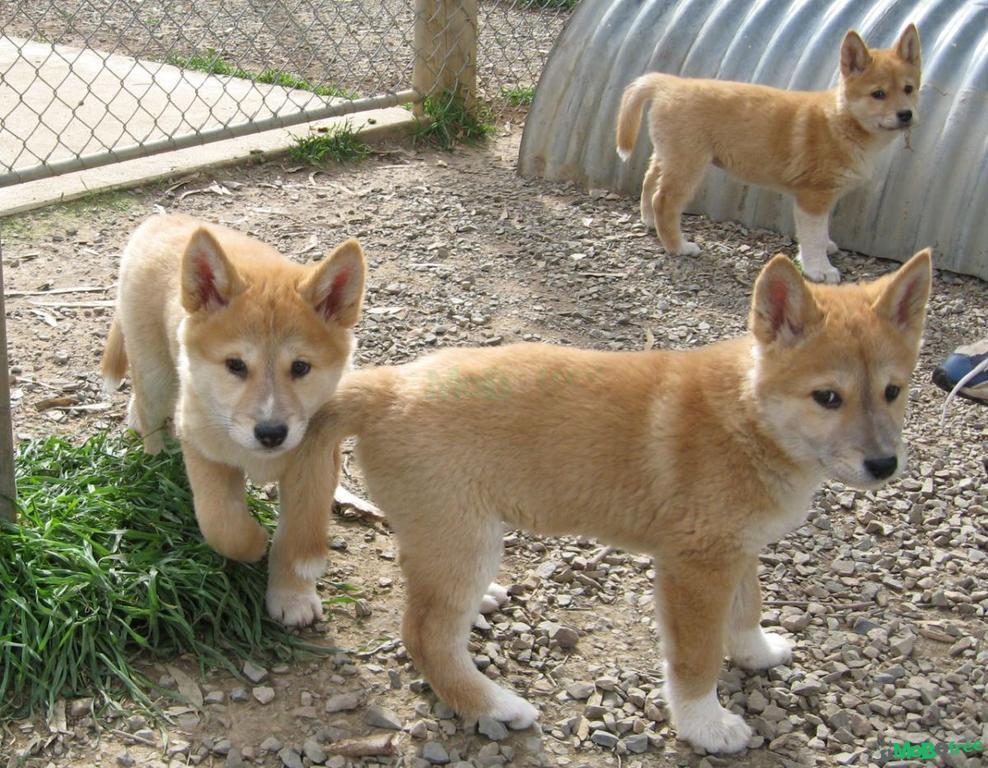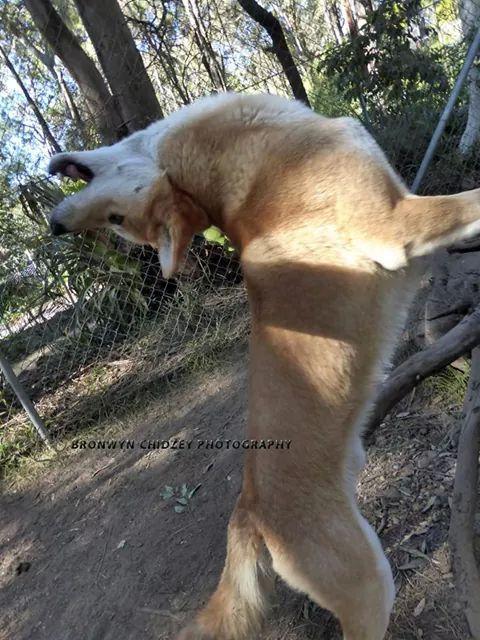The first image is the image on the left, the second image is the image on the right. For the images shown, is this caption "Each image contains a single dingo, and one is in an upright sitting pose, while the other is standing on all fours." true? Answer yes or no. No. The first image is the image on the left, the second image is the image on the right. Analyze the images presented: Is the assertion "Atleast one image of a dog sitting or laying down." valid? Answer yes or no. No. 